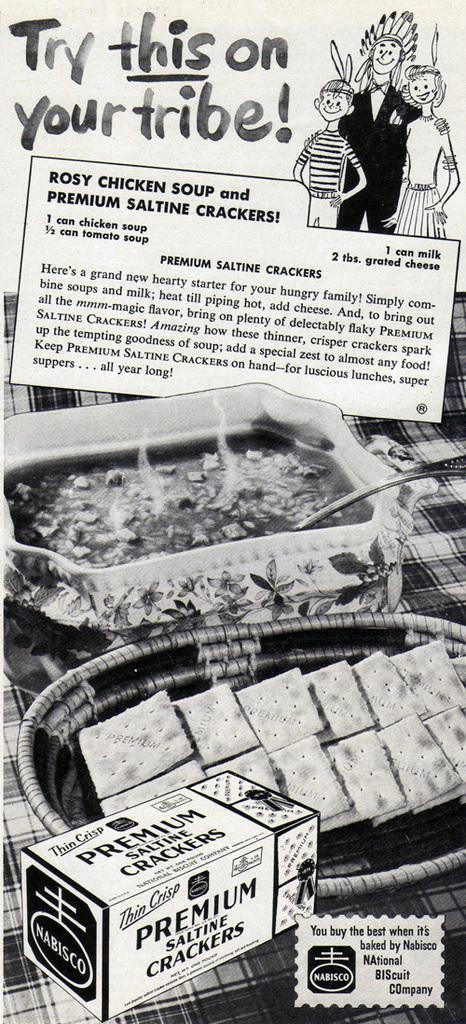In one or two sentences, can you explain what this image depicts? This is a black and white pic. We can see food items in the plates, spoons on a platform. There are cartoon pictures, texts, picture of a box on the image. 